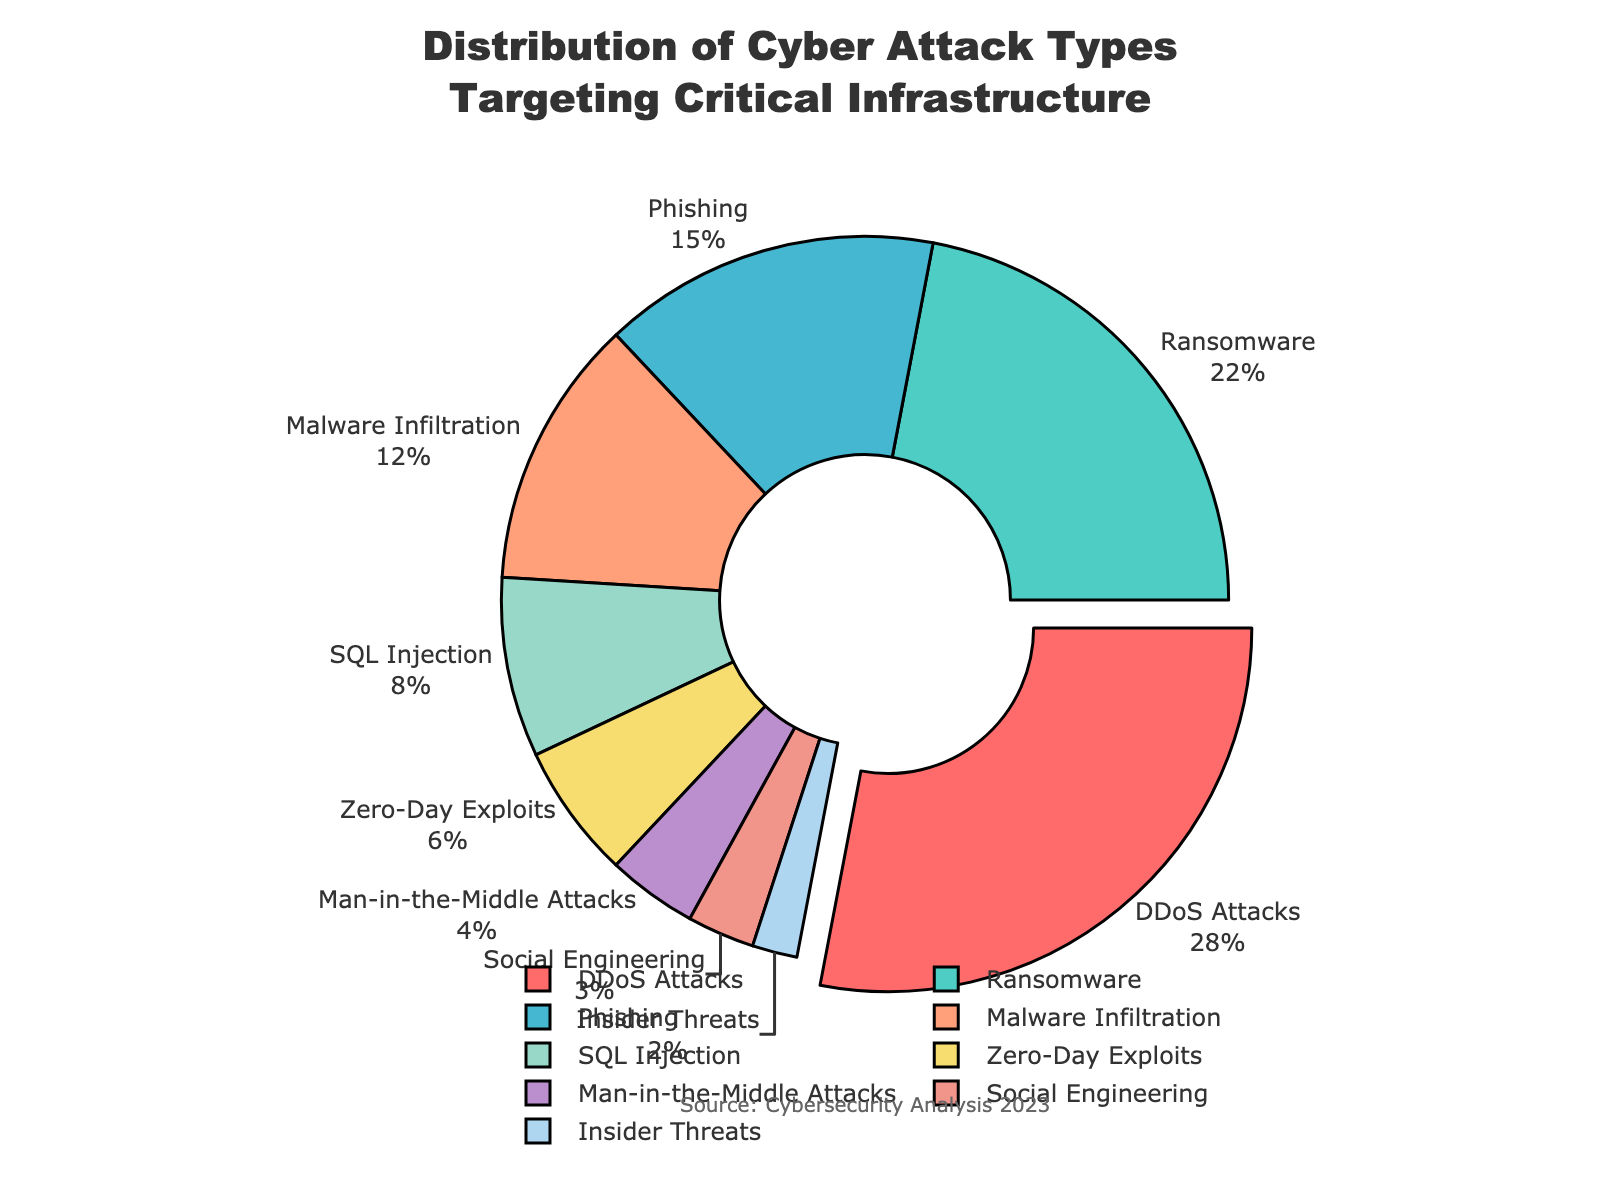Which attack type has the largest share in the distribution? Look at the wedges of the pie chart and identify the one with the largest percentage value. According to the visual representation, "DDoS Attacks" has the largest slice.
Answer: DDoS Attacks How much more prevalent are DDoS Attacks compared to Insider Threats? Subtract the percentage of Insider Threats from the percentage of DDoS Attacks: 28% - 2% = 26%.
Answer: 26% What is the total percentage of Phishing and Social Engineering attacks combined? Add the percentages of Phishing (15%) and Social Engineering (3%) together: 15% + 3% = 18%.
Answer: 18% Compare the prevalence of Malware Infiltration with Zero-Day Exploits. Which one is higher and by how much? Malware Infiltration is 12%, and Zero-Day Exploits is 6%. Subtract the percentage of Zero-Day Exploits from Malware Infiltration: 12% - 6% = 6%.
Answer: Malware Infiltration is higher by 6% Which visual feature signals the highest percentage in the pie chart? The slice representing DDoS Attacks is pulled out slightly compared to the other slices, indicating that it has the highest percentage.
Answer: Pulled out slice What percentage of cyber attacks are not related to Ransomware or Phishing? Add the percentages of Ransomware (22%) and Phishing (15%) first: 22% + 15% = 37%. Then subtract this from 100%: 100% - 37% = 63%.
Answer: 63% Rank the top three cyber attack types in descending order. Refer to the percentages of each attack type and list the top three: DDoS Attacks (28%), Ransomware (22%), and Phishing (15%).
Answer: DDoS Attacks, Ransomware, Phishing Is the percentage of SQL Injection attacks greater than that of Social Engineering and Insider Threats combined? First, combine the percentages of Social Engineering (3%) and Insider Threats (2%): 3% + 2% = 5%. Since SQL Injection is 8%, it is greater than 5%.
Answer: Yes What is the total percentage contributed by DDoS Attacks, Ransomware, and Malware Infiltration? Add the percentages of these attacks: 28% + 22% + 12% = 62%.
Answer: 62% 